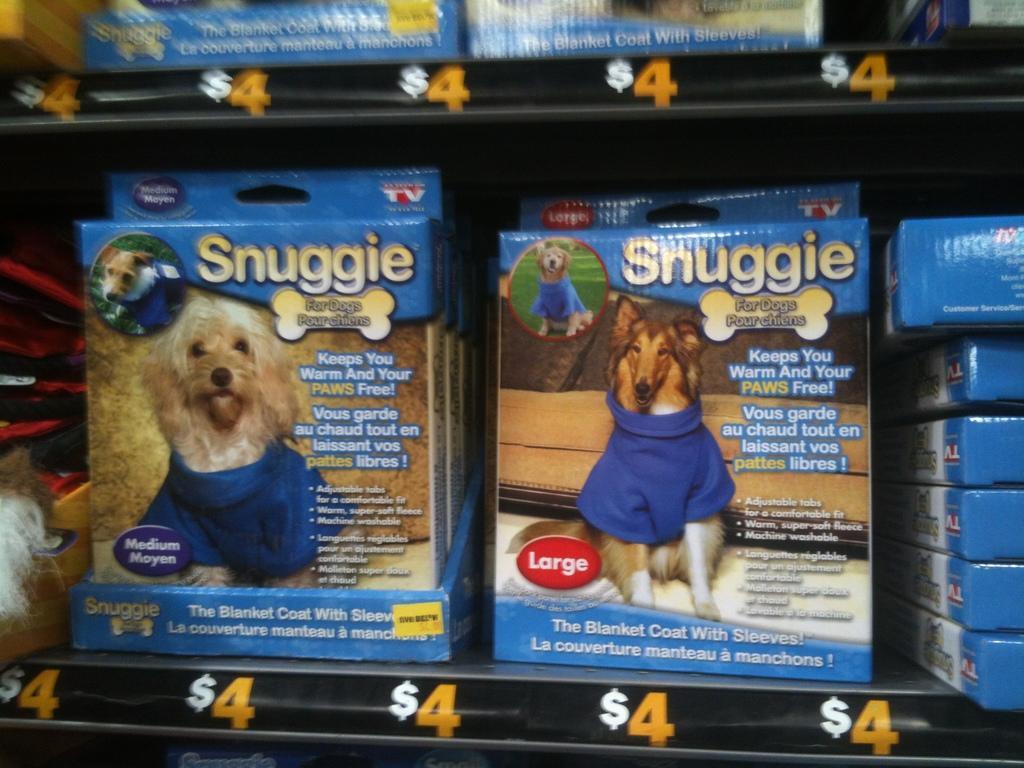Please provide a concise description of this image. This image is taken indoors. In this image there are two shelves with many boxes on them. There are a few images of dogs and there is a text on the boxes. 